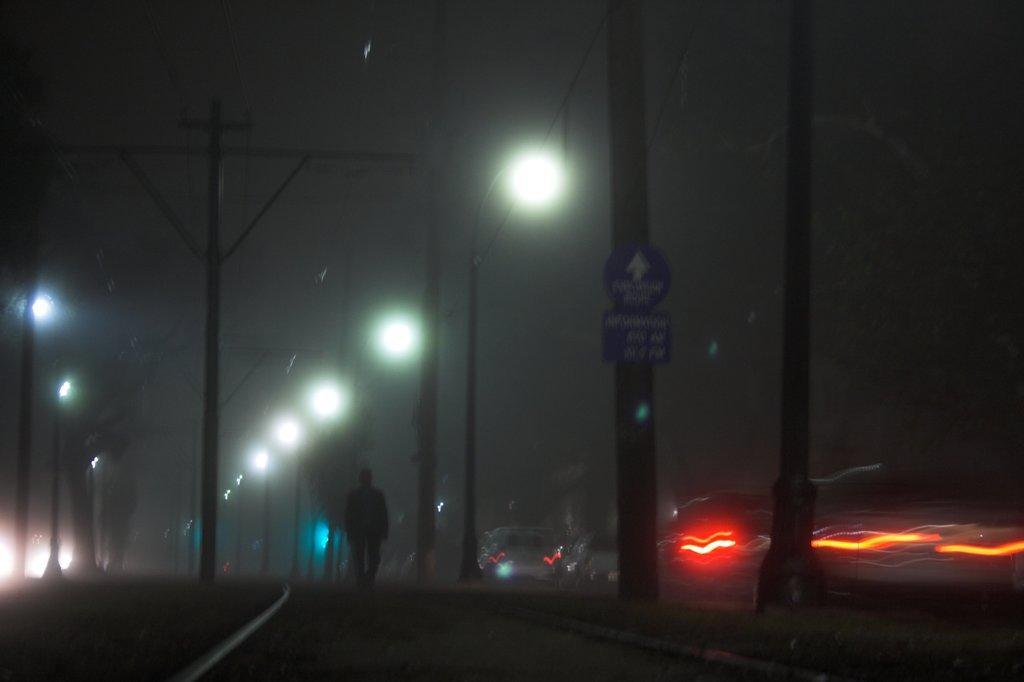In one or two sentences, can you explain what this image depicts? In the picture I can see one person is walking. On the right and left side of the image I can lights, And this is dark image. 